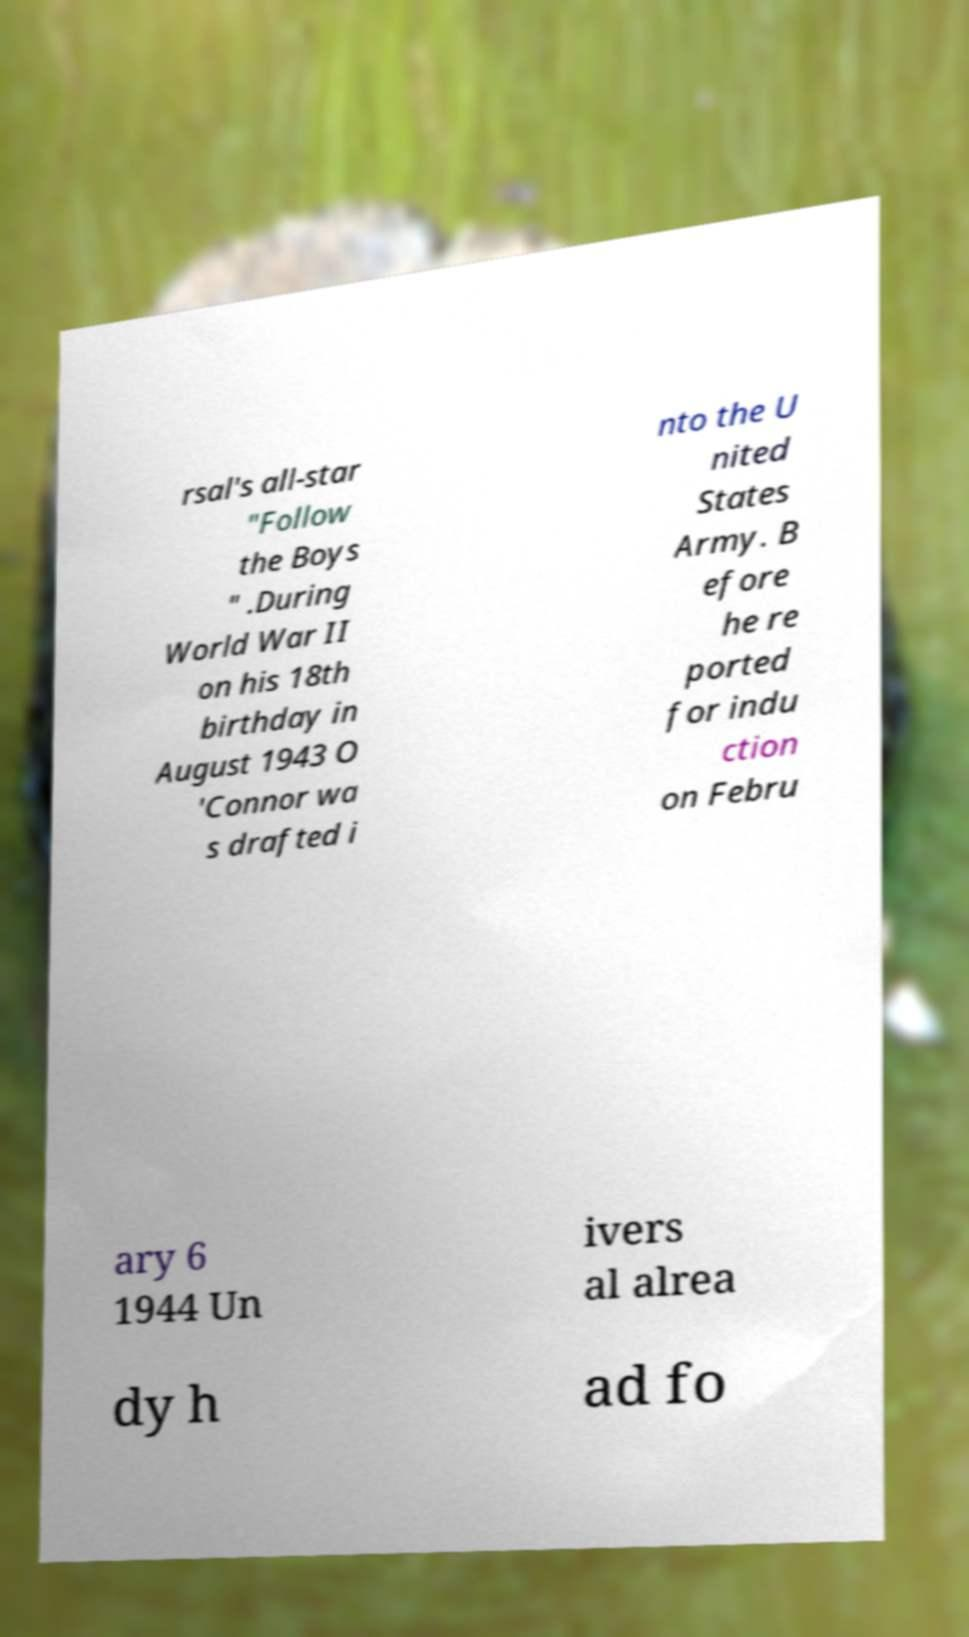For documentation purposes, I need the text within this image transcribed. Could you provide that? rsal's all-star "Follow the Boys " .During World War II on his 18th birthday in August 1943 O 'Connor wa s drafted i nto the U nited States Army. B efore he re ported for indu ction on Febru ary 6 1944 Un ivers al alrea dy h ad fo 